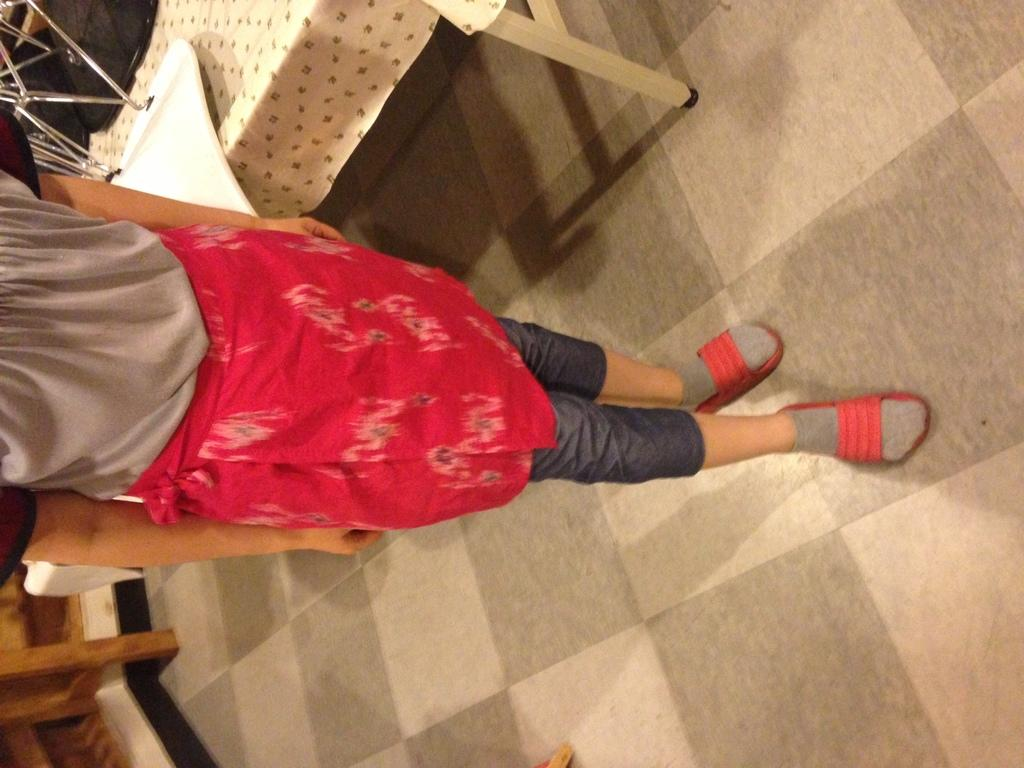What is the main subject of the image? There is a person standing in the image. Can you describe the person's clothing? The person is wearing a red and brown color dress. What can be seen in the background of the image? There are tables and a brown-colored cloth visible in the background. What type of structure is being built with a hammer in the image? There is no structure or hammer present in the image. 